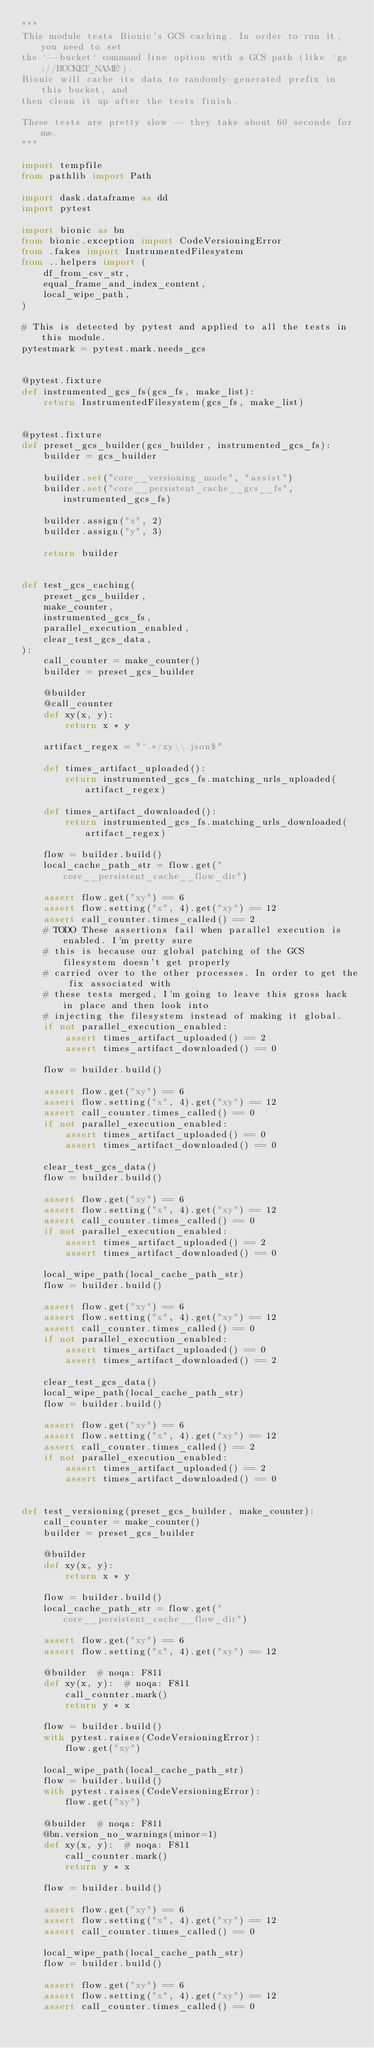Convert code to text. <code><loc_0><loc_0><loc_500><loc_500><_Python_>"""
This module tests Bionic's GCS caching. In order to run it, you need to set
the `--bucket` command line option with a GCS path (like `gs://BUCKET_NAME`).
Bionic will cache its data to randomly-generated prefix in this bucket, and
then clean it up after the tests finish.

These tests are pretty slow -- they take about 60 seconds for me.
"""

import tempfile
from pathlib import Path

import dask.dataframe as dd
import pytest

import bionic as bn
from bionic.exception import CodeVersioningError
from .fakes import InstrumentedFilesystem
from ..helpers import (
    df_from_csv_str,
    equal_frame_and_index_content,
    local_wipe_path,
)

# This is detected by pytest and applied to all the tests in this module.
pytestmark = pytest.mark.needs_gcs


@pytest.fixture
def instrumented_gcs_fs(gcs_fs, make_list):
    return InstrumentedFilesystem(gcs_fs, make_list)


@pytest.fixture
def preset_gcs_builder(gcs_builder, instrumented_gcs_fs):
    builder = gcs_builder

    builder.set("core__versioning_mode", "assist")
    builder.set("core__persistent_cache__gcs__fs", instrumented_gcs_fs)

    builder.assign("x", 2)
    builder.assign("y", 3)

    return builder


def test_gcs_caching(
    preset_gcs_builder,
    make_counter,
    instrumented_gcs_fs,
    parallel_execution_enabled,
    clear_test_gcs_data,
):
    call_counter = make_counter()
    builder = preset_gcs_builder

    @builder
    @call_counter
    def xy(x, y):
        return x * y

    artifact_regex = "^.*/xy\\.json$"

    def times_artifact_uploaded():
        return instrumented_gcs_fs.matching_urls_uploaded(artifact_regex)

    def times_artifact_downloaded():
        return instrumented_gcs_fs.matching_urls_downloaded(artifact_regex)

    flow = builder.build()
    local_cache_path_str = flow.get("core__persistent_cache__flow_dir")

    assert flow.get("xy") == 6
    assert flow.setting("x", 4).get("xy") == 12
    assert call_counter.times_called() == 2
    # TODO These assertions fail when parallel execution is enabled. I'm pretty sure
    # this is because our global patching of the GCS filesystem doesn't get properly
    # carried over to the other processes. In order to get the fix associated with
    # these tests merged, I'm going to leave this gross hack in place and then look into
    # injecting the filesystem instead of making it global.
    if not parallel_execution_enabled:
        assert times_artifact_uploaded() == 2
        assert times_artifact_downloaded() == 0

    flow = builder.build()

    assert flow.get("xy") == 6
    assert flow.setting("x", 4).get("xy") == 12
    assert call_counter.times_called() == 0
    if not parallel_execution_enabled:
        assert times_artifact_uploaded() == 0
        assert times_artifact_downloaded() == 0

    clear_test_gcs_data()
    flow = builder.build()

    assert flow.get("xy") == 6
    assert flow.setting("x", 4).get("xy") == 12
    assert call_counter.times_called() == 0
    if not parallel_execution_enabled:
        assert times_artifact_uploaded() == 2
        assert times_artifact_downloaded() == 0

    local_wipe_path(local_cache_path_str)
    flow = builder.build()

    assert flow.get("xy") == 6
    assert flow.setting("x", 4).get("xy") == 12
    assert call_counter.times_called() == 0
    if not parallel_execution_enabled:
        assert times_artifact_uploaded() == 0
        assert times_artifact_downloaded() == 2

    clear_test_gcs_data()
    local_wipe_path(local_cache_path_str)
    flow = builder.build()

    assert flow.get("xy") == 6
    assert flow.setting("x", 4).get("xy") == 12
    assert call_counter.times_called() == 2
    if not parallel_execution_enabled:
        assert times_artifact_uploaded() == 2
        assert times_artifact_downloaded() == 0


def test_versioning(preset_gcs_builder, make_counter):
    call_counter = make_counter()
    builder = preset_gcs_builder

    @builder
    def xy(x, y):
        return x * y

    flow = builder.build()
    local_cache_path_str = flow.get("core__persistent_cache__flow_dir")

    assert flow.get("xy") == 6
    assert flow.setting("x", 4).get("xy") == 12

    @builder  # noqa: F811
    def xy(x, y):  # noqa: F811
        call_counter.mark()
        return y * x

    flow = builder.build()
    with pytest.raises(CodeVersioningError):
        flow.get("xy")

    local_wipe_path(local_cache_path_str)
    flow = builder.build()
    with pytest.raises(CodeVersioningError):
        flow.get("xy")

    @builder  # noqa: F811
    @bn.version_no_warnings(minor=1)
    def xy(x, y):  # noqa: F811
        call_counter.mark()
        return y * x

    flow = builder.build()

    assert flow.get("xy") == 6
    assert flow.setting("x", 4).get("xy") == 12
    assert call_counter.times_called() == 0

    local_wipe_path(local_cache_path_str)
    flow = builder.build()

    assert flow.get("xy") == 6
    assert flow.setting("x", 4).get("xy") == 12
    assert call_counter.times_called() == 0
</code> 